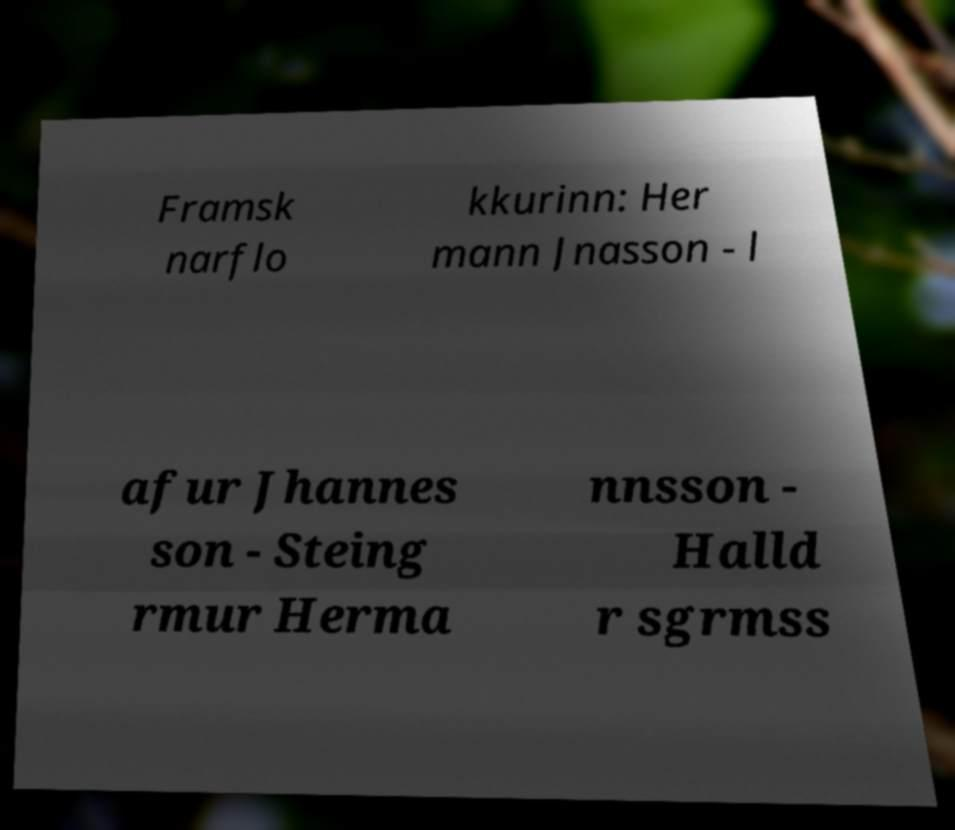Please identify and transcribe the text found in this image. Framsk narflo kkurinn: Her mann Jnasson - l afur Jhannes son - Steing rmur Herma nnsson - Halld r sgrmss 